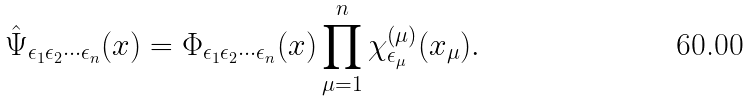<formula> <loc_0><loc_0><loc_500><loc_500>\hat { \Psi } _ { \epsilon _ { 1 } \epsilon _ { 2 } \cdots \epsilon _ { n } } ( x ) = \Phi _ { \epsilon _ { 1 } \epsilon _ { 2 } \cdots \epsilon _ { n } } ( x ) \prod _ { \mu = 1 } ^ { n } \chi ^ { ( \mu ) } _ { \epsilon _ { \mu } } ( x _ { \mu } ) .</formula> 